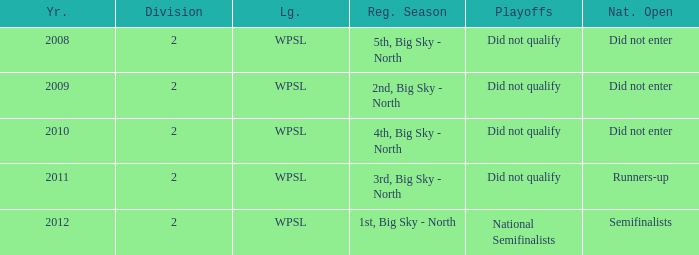What league was involved in 2010? WPSL. 